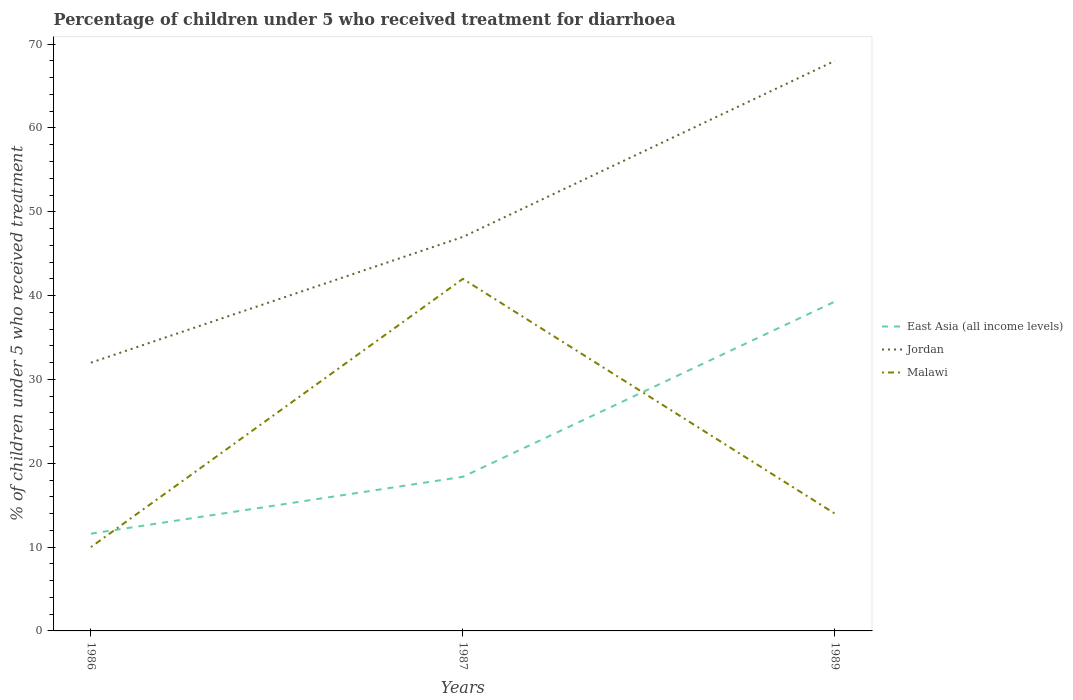How many different coloured lines are there?
Your response must be concise. 3. Across all years, what is the maximum percentage of children who received treatment for diarrhoea  in Jordan?
Give a very brief answer. 32. What is the total percentage of children who received treatment for diarrhoea  in Malawi in the graph?
Your answer should be very brief. 28. What is the difference between the highest and the lowest percentage of children who received treatment for diarrhoea  in East Asia (all income levels)?
Provide a short and direct response. 1. How many lines are there?
Make the answer very short. 3. Where does the legend appear in the graph?
Ensure brevity in your answer.  Center right. How are the legend labels stacked?
Make the answer very short. Vertical. What is the title of the graph?
Make the answer very short. Percentage of children under 5 who received treatment for diarrhoea. Does "Ghana" appear as one of the legend labels in the graph?
Your answer should be compact. No. What is the label or title of the Y-axis?
Provide a succinct answer. % of children under 5 who received treatment. What is the % of children under 5 who received treatment in East Asia (all income levels) in 1986?
Offer a very short reply. 11.6. What is the % of children under 5 who received treatment in Jordan in 1986?
Your answer should be very brief. 32. What is the % of children under 5 who received treatment in Malawi in 1986?
Your answer should be compact. 10. What is the % of children under 5 who received treatment in East Asia (all income levels) in 1987?
Your answer should be very brief. 18.39. What is the % of children under 5 who received treatment in Jordan in 1987?
Provide a succinct answer. 47. What is the % of children under 5 who received treatment in East Asia (all income levels) in 1989?
Offer a terse response. 39.29. What is the % of children under 5 who received treatment in Jordan in 1989?
Provide a short and direct response. 68. Across all years, what is the maximum % of children under 5 who received treatment in East Asia (all income levels)?
Your response must be concise. 39.29. Across all years, what is the minimum % of children under 5 who received treatment in East Asia (all income levels)?
Your answer should be compact. 11.6. What is the total % of children under 5 who received treatment in East Asia (all income levels) in the graph?
Ensure brevity in your answer.  69.27. What is the total % of children under 5 who received treatment of Jordan in the graph?
Keep it short and to the point. 147. What is the difference between the % of children under 5 who received treatment in East Asia (all income levels) in 1986 and that in 1987?
Your answer should be compact. -6.78. What is the difference between the % of children under 5 who received treatment of Malawi in 1986 and that in 1987?
Give a very brief answer. -32. What is the difference between the % of children under 5 who received treatment in East Asia (all income levels) in 1986 and that in 1989?
Offer a very short reply. -27.68. What is the difference between the % of children under 5 who received treatment of Jordan in 1986 and that in 1989?
Your answer should be compact. -36. What is the difference between the % of children under 5 who received treatment of Malawi in 1986 and that in 1989?
Give a very brief answer. -4. What is the difference between the % of children under 5 who received treatment of East Asia (all income levels) in 1987 and that in 1989?
Provide a short and direct response. -20.9. What is the difference between the % of children under 5 who received treatment of Jordan in 1987 and that in 1989?
Your response must be concise. -21. What is the difference between the % of children under 5 who received treatment of East Asia (all income levels) in 1986 and the % of children under 5 who received treatment of Jordan in 1987?
Your response must be concise. -35.4. What is the difference between the % of children under 5 who received treatment in East Asia (all income levels) in 1986 and the % of children under 5 who received treatment in Malawi in 1987?
Keep it short and to the point. -30.4. What is the difference between the % of children under 5 who received treatment in East Asia (all income levels) in 1986 and the % of children under 5 who received treatment in Jordan in 1989?
Give a very brief answer. -56.4. What is the difference between the % of children under 5 who received treatment in East Asia (all income levels) in 1986 and the % of children under 5 who received treatment in Malawi in 1989?
Your response must be concise. -2.4. What is the difference between the % of children under 5 who received treatment of Jordan in 1986 and the % of children under 5 who received treatment of Malawi in 1989?
Offer a very short reply. 18. What is the difference between the % of children under 5 who received treatment in East Asia (all income levels) in 1987 and the % of children under 5 who received treatment in Jordan in 1989?
Make the answer very short. -49.61. What is the difference between the % of children under 5 who received treatment of East Asia (all income levels) in 1987 and the % of children under 5 who received treatment of Malawi in 1989?
Keep it short and to the point. 4.39. What is the difference between the % of children under 5 who received treatment of Jordan in 1987 and the % of children under 5 who received treatment of Malawi in 1989?
Your response must be concise. 33. What is the average % of children under 5 who received treatment in East Asia (all income levels) per year?
Your response must be concise. 23.09. In the year 1986, what is the difference between the % of children under 5 who received treatment in East Asia (all income levels) and % of children under 5 who received treatment in Jordan?
Ensure brevity in your answer.  -20.4. In the year 1986, what is the difference between the % of children under 5 who received treatment of East Asia (all income levels) and % of children under 5 who received treatment of Malawi?
Your answer should be compact. 1.6. In the year 1986, what is the difference between the % of children under 5 who received treatment of Jordan and % of children under 5 who received treatment of Malawi?
Offer a very short reply. 22. In the year 1987, what is the difference between the % of children under 5 who received treatment of East Asia (all income levels) and % of children under 5 who received treatment of Jordan?
Offer a terse response. -28.61. In the year 1987, what is the difference between the % of children under 5 who received treatment of East Asia (all income levels) and % of children under 5 who received treatment of Malawi?
Your answer should be compact. -23.61. In the year 1987, what is the difference between the % of children under 5 who received treatment of Jordan and % of children under 5 who received treatment of Malawi?
Keep it short and to the point. 5. In the year 1989, what is the difference between the % of children under 5 who received treatment of East Asia (all income levels) and % of children under 5 who received treatment of Jordan?
Your answer should be very brief. -28.71. In the year 1989, what is the difference between the % of children under 5 who received treatment in East Asia (all income levels) and % of children under 5 who received treatment in Malawi?
Ensure brevity in your answer.  25.29. In the year 1989, what is the difference between the % of children under 5 who received treatment in Jordan and % of children under 5 who received treatment in Malawi?
Ensure brevity in your answer.  54. What is the ratio of the % of children under 5 who received treatment in East Asia (all income levels) in 1986 to that in 1987?
Your response must be concise. 0.63. What is the ratio of the % of children under 5 who received treatment in Jordan in 1986 to that in 1987?
Your response must be concise. 0.68. What is the ratio of the % of children under 5 who received treatment of Malawi in 1986 to that in 1987?
Your answer should be very brief. 0.24. What is the ratio of the % of children under 5 who received treatment in East Asia (all income levels) in 1986 to that in 1989?
Your response must be concise. 0.3. What is the ratio of the % of children under 5 who received treatment in Jordan in 1986 to that in 1989?
Ensure brevity in your answer.  0.47. What is the ratio of the % of children under 5 who received treatment in Malawi in 1986 to that in 1989?
Your answer should be very brief. 0.71. What is the ratio of the % of children under 5 who received treatment of East Asia (all income levels) in 1987 to that in 1989?
Give a very brief answer. 0.47. What is the ratio of the % of children under 5 who received treatment in Jordan in 1987 to that in 1989?
Your answer should be compact. 0.69. What is the ratio of the % of children under 5 who received treatment of Malawi in 1987 to that in 1989?
Provide a succinct answer. 3. What is the difference between the highest and the second highest % of children under 5 who received treatment in East Asia (all income levels)?
Give a very brief answer. 20.9. What is the difference between the highest and the lowest % of children under 5 who received treatment of East Asia (all income levels)?
Make the answer very short. 27.68. What is the difference between the highest and the lowest % of children under 5 who received treatment in Malawi?
Your answer should be compact. 32. 